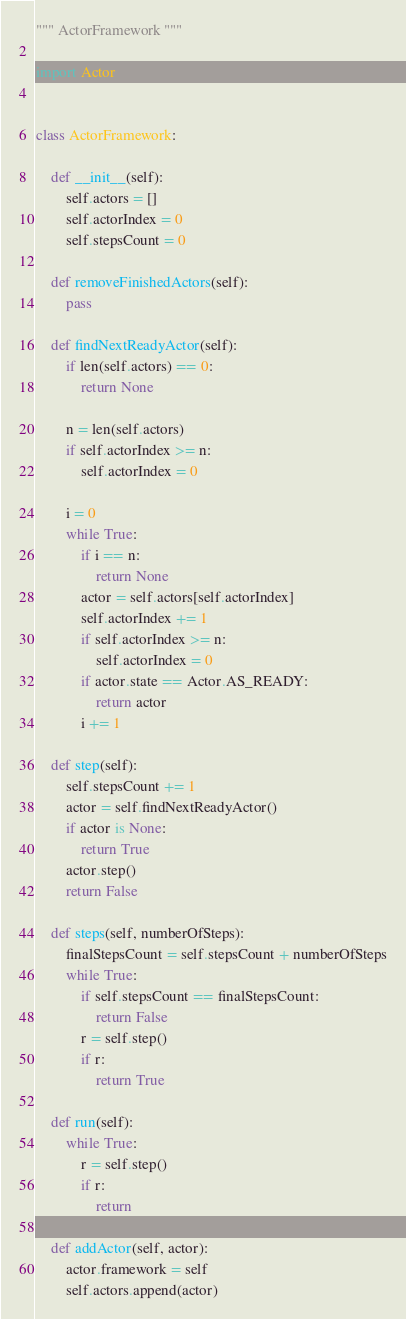Convert code to text. <code><loc_0><loc_0><loc_500><loc_500><_Python_>""" ActorFramework """

import Actor


class ActorFramework:

    def __init__(self):
        self.actors = []
        self.actorIndex = 0
        self.stepsCount = 0

    def removeFinishedActors(self):
        pass

    def findNextReadyActor(self):
        if len(self.actors) == 0:
            return None

        n = len(self.actors)
        if self.actorIndex >= n:
            self.actorIndex = 0

        i = 0
        while True:
            if i == n:
                return None
            actor = self.actors[self.actorIndex]
            self.actorIndex += 1
            if self.actorIndex >= n:
                self.actorIndex = 0
            if actor.state == Actor.AS_READY:
                return actor
            i += 1

    def step(self):
        self.stepsCount += 1
        actor = self.findNextReadyActor()
        if actor is None:
            return True
        actor.step()
        return False

    def steps(self, numberOfSteps):
        finalStepsCount = self.stepsCount + numberOfSteps
        while True:
            if self.stepsCount == finalStepsCount:
                return False
            r = self.step()
            if r:
                return True

    def run(self):
        while True:
            r = self.step()
            if r:
                return

    def addActor(self, actor):
        actor.framework = self
        self.actors.append(actor)

</code> 